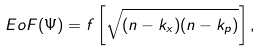Convert formula to latex. <formula><loc_0><loc_0><loc_500><loc_500>E o F ( \Psi ) = f \left [ \sqrt { ( n - k _ { x } ) ( n - k _ { p } ) } \right ] ,</formula> 